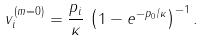<formula> <loc_0><loc_0><loc_500><loc_500>v ^ { ( m = 0 ) } _ { i } = \frac { p _ { i } } \kappa \, \left ( 1 - e ^ { - { p _ { 0 } } / \kappa } \right ) ^ { - 1 } .</formula> 